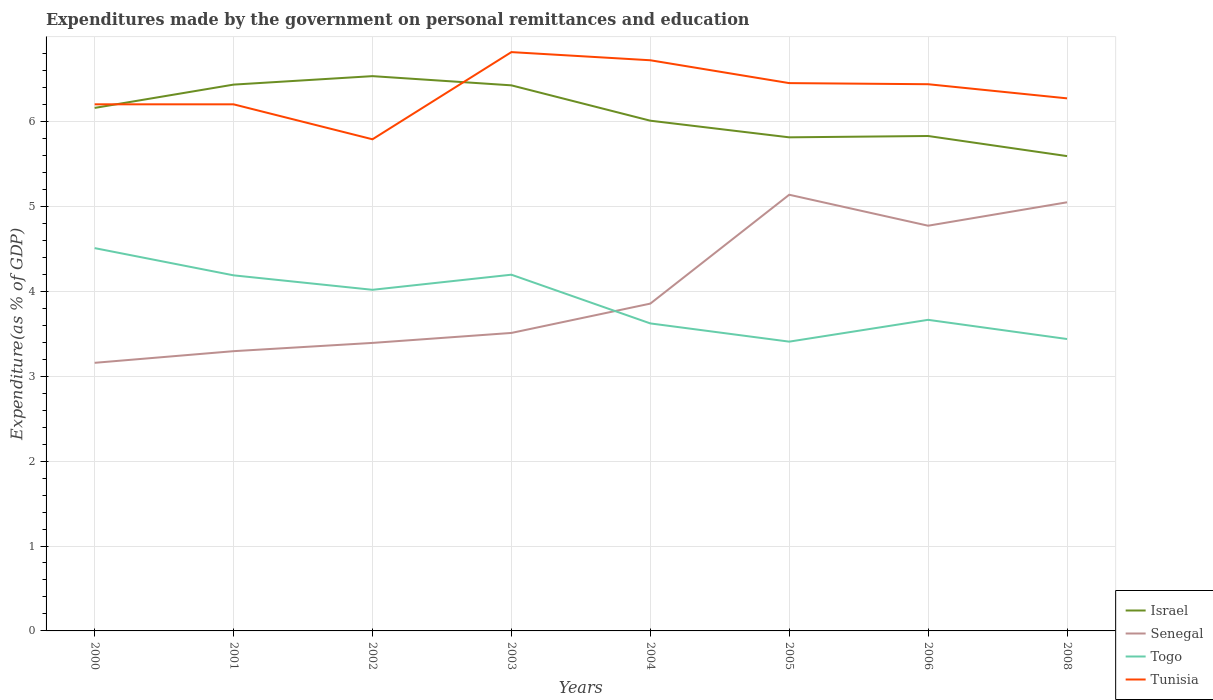How many different coloured lines are there?
Offer a very short reply. 4. Is the number of lines equal to the number of legend labels?
Give a very brief answer. Yes. Across all years, what is the maximum expenditures made by the government on personal remittances and education in Togo?
Your response must be concise. 3.41. What is the total expenditures made by the government on personal remittances and education in Senegal in the graph?
Make the answer very short. -0.12. What is the difference between the highest and the second highest expenditures made by the government on personal remittances and education in Togo?
Your answer should be compact. 1.1. What is the title of the graph?
Provide a succinct answer. Expenditures made by the government on personal remittances and education. Does "India" appear as one of the legend labels in the graph?
Give a very brief answer. No. What is the label or title of the Y-axis?
Offer a very short reply. Expenditure(as % of GDP). What is the Expenditure(as % of GDP) of Israel in 2000?
Your answer should be very brief. 6.16. What is the Expenditure(as % of GDP) in Senegal in 2000?
Make the answer very short. 3.16. What is the Expenditure(as % of GDP) of Togo in 2000?
Your response must be concise. 4.51. What is the Expenditure(as % of GDP) in Tunisia in 2000?
Provide a short and direct response. 6.2. What is the Expenditure(as % of GDP) of Israel in 2001?
Offer a terse response. 6.43. What is the Expenditure(as % of GDP) of Senegal in 2001?
Your answer should be very brief. 3.29. What is the Expenditure(as % of GDP) in Togo in 2001?
Offer a very short reply. 4.19. What is the Expenditure(as % of GDP) in Tunisia in 2001?
Provide a short and direct response. 6.2. What is the Expenditure(as % of GDP) of Israel in 2002?
Your answer should be compact. 6.53. What is the Expenditure(as % of GDP) in Senegal in 2002?
Offer a very short reply. 3.39. What is the Expenditure(as % of GDP) in Togo in 2002?
Your response must be concise. 4.02. What is the Expenditure(as % of GDP) of Tunisia in 2002?
Provide a short and direct response. 5.79. What is the Expenditure(as % of GDP) in Israel in 2003?
Your answer should be very brief. 6.43. What is the Expenditure(as % of GDP) of Senegal in 2003?
Give a very brief answer. 3.51. What is the Expenditure(as % of GDP) in Togo in 2003?
Ensure brevity in your answer.  4.2. What is the Expenditure(as % of GDP) of Tunisia in 2003?
Your response must be concise. 6.82. What is the Expenditure(as % of GDP) of Israel in 2004?
Offer a very short reply. 6.01. What is the Expenditure(as % of GDP) in Senegal in 2004?
Keep it short and to the point. 3.85. What is the Expenditure(as % of GDP) of Togo in 2004?
Give a very brief answer. 3.62. What is the Expenditure(as % of GDP) of Tunisia in 2004?
Offer a very short reply. 6.72. What is the Expenditure(as % of GDP) in Israel in 2005?
Your response must be concise. 5.81. What is the Expenditure(as % of GDP) in Senegal in 2005?
Ensure brevity in your answer.  5.14. What is the Expenditure(as % of GDP) in Togo in 2005?
Keep it short and to the point. 3.41. What is the Expenditure(as % of GDP) of Tunisia in 2005?
Offer a very short reply. 6.45. What is the Expenditure(as % of GDP) of Israel in 2006?
Your answer should be compact. 5.83. What is the Expenditure(as % of GDP) of Senegal in 2006?
Make the answer very short. 4.77. What is the Expenditure(as % of GDP) of Togo in 2006?
Your response must be concise. 3.66. What is the Expenditure(as % of GDP) of Tunisia in 2006?
Offer a very short reply. 6.44. What is the Expenditure(as % of GDP) in Israel in 2008?
Ensure brevity in your answer.  5.59. What is the Expenditure(as % of GDP) of Senegal in 2008?
Ensure brevity in your answer.  5.05. What is the Expenditure(as % of GDP) of Togo in 2008?
Keep it short and to the point. 3.44. What is the Expenditure(as % of GDP) in Tunisia in 2008?
Offer a terse response. 6.27. Across all years, what is the maximum Expenditure(as % of GDP) of Israel?
Provide a short and direct response. 6.53. Across all years, what is the maximum Expenditure(as % of GDP) of Senegal?
Provide a short and direct response. 5.14. Across all years, what is the maximum Expenditure(as % of GDP) of Togo?
Your answer should be very brief. 4.51. Across all years, what is the maximum Expenditure(as % of GDP) in Tunisia?
Offer a very short reply. 6.82. Across all years, what is the minimum Expenditure(as % of GDP) in Israel?
Provide a succinct answer. 5.59. Across all years, what is the minimum Expenditure(as % of GDP) of Senegal?
Make the answer very short. 3.16. Across all years, what is the minimum Expenditure(as % of GDP) in Togo?
Your answer should be compact. 3.41. Across all years, what is the minimum Expenditure(as % of GDP) in Tunisia?
Keep it short and to the point. 5.79. What is the total Expenditure(as % of GDP) in Israel in the graph?
Your answer should be very brief. 48.8. What is the total Expenditure(as % of GDP) in Senegal in the graph?
Make the answer very short. 32.17. What is the total Expenditure(as % of GDP) of Togo in the graph?
Your response must be concise. 31.04. What is the total Expenditure(as % of GDP) of Tunisia in the graph?
Make the answer very short. 50.89. What is the difference between the Expenditure(as % of GDP) of Israel in 2000 and that in 2001?
Keep it short and to the point. -0.27. What is the difference between the Expenditure(as % of GDP) of Senegal in 2000 and that in 2001?
Ensure brevity in your answer.  -0.14. What is the difference between the Expenditure(as % of GDP) of Togo in 2000 and that in 2001?
Give a very brief answer. 0.32. What is the difference between the Expenditure(as % of GDP) in Tunisia in 2000 and that in 2001?
Keep it short and to the point. 0. What is the difference between the Expenditure(as % of GDP) of Israel in 2000 and that in 2002?
Provide a short and direct response. -0.37. What is the difference between the Expenditure(as % of GDP) of Senegal in 2000 and that in 2002?
Your answer should be compact. -0.23. What is the difference between the Expenditure(as % of GDP) in Togo in 2000 and that in 2002?
Keep it short and to the point. 0.49. What is the difference between the Expenditure(as % of GDP) in Tunisia in 2000 and that in 2002?
Your response must be concise. 0.41. What is the difference between the Expenditure(as % of GDP) in Israel in 2000 and that in 2003?
Keep it short and to the point. -0.27. What is the difference between the Expenditure(as % of GDP) of Senegal in 2000 and that in 2003?
Offer a very short reply. -0.35. What is the difference between the Expenditure(as % of GDP) in Togo in 2000 and that in 2003?
Your answer should be compact. 0.31. What is the difference between the Expenditure(as % of GDP) in Tunisia in 2000 and that in 2003?
Offer a very short reply. -0.61. What is the difference between the Expenditure(as % of GDP) in Israel in 2000 and that in 2004?
Make the answer very short. 0.15. What is the difference between the Expenditure(as % of GDP) in Senegal in 2000 and that in 2004?
Make the answer very short. -0.7. What is the difference between the Expenditure(as % of GDP) in Togo in 2000 and that in 2004?
Your answer should be compact. 0.89. What is the difference between the Expenditure(as % of GDP) of Tunisia in 2000 and that in 2004?
Provide a short and direct response. -0.52. What is the difference between the Expenditure(as % of GDP) of Israel in 2000 and that in 2005?
Your answer should be very brief. 0.35. What is the difference between the Expenditure(as % of GDP) of Senegal in 2000 and that in 2005?
Your answer should be very brief. -1.98. What is the difference between the Expenditure(as % of GDP) of Togo in 2000 and that in 2005?
Provide a short and direct response. 1.1. What is the difference between the Expenditure(as % of GDP) in Tunisia in 2000 and that in 2005?
Give a very brief answer. -0.25. What is the difference between the Expenditure(as % of GDP) in Israel in 2000 and that in 2006?
Ensure brevity in your answer.  0.33. What is the difference between the Expenditure(as % of GDP) of Senegal in 2000 and that in 2006?
Make the answer very short. -1.61. What is the difference between the Expenditure(as % of GDP) in Togo in 2000 and that in 2006?
Give a very brief answer. 0.84. What is the difference between the Expenditure(as % of GDP) of Tunisia in 2000 and that in 2006?
Make the answer very short. -0.24. What is the difference between the Expenditure(as % of GDP) in Israel in 2000 and that in 2008?
Your answer should be compact. 0.57. What is the difference between the Expenditure(as % of GDP) of Senegal in 2000 and that in 2008?
Keep it short and to the point. -1.89. What is the difference between the Expenditure(as % of GDP) of Togo in 2000 and that in 2008?
Keep it short and to the point. 1.07. What is the difference between the Expenditure(as % of GDP) of Tunisia in 2000 and that in 2008?
Offer a terse response. -0.07. What is the difference between the Expenditure(as % of GDP) of Israel in 2001 and that in 2002?
Make the answer very short. -0.1. What is the difference between the Expenditure(as % of GDP) in Senegal in 2001 and that in 2002?
Offer a very short reply. -0.1. What is the difference between the Expenditure(as % of GDP) in Togo in 2001 and that in 2002?
Your answer should be very brief. 0.17. What is the difference between the Expenditure(as % of GDP) of Tunisia in 2001 and that in 2002?
Offer a terse response. 0.41. What is the difference between the Expenditure(as % of GDP) in Israel in 2001 and that in 2003?
Offer a very short reply. 0.01. What is the difference between the Expenditure(as % of GDP) in Senegal in 2001 and that in 2003?
Keep it short and to the point. -0.21. What is the difference between the Expenditure(as % of GDP) of Togo in 2001 and that in 2003?
Offer a terse response. -0.01. What is the difference between the Expenditure(as % of GDP) of Tunisia in 2001 and that in 2003?
Offer a terse response. -0.61. What is the difference between the Expenditure(as % of GDP) in Israel in 2001 and that in 2004?
Give a very brief answer. 0.42. What is the difference between the Expenditure(as % of GDP) of Senegal in 2001 and that in 2004?
Ensure brevity in your answer.  -0.56. What is the difference between the Expenditure(as % of GDP) of Togo in 2001 and that in 2004?
Your response must be concise. 0.57. What is the difference between the Expenditure(as % of GDP) of Tunisia in 2001 and that in 2004?
Your answer should be compact. -0.52. What is the difference between the Expenditure(as % of GDP) of Israel in 2001 and that in 2005?
Keep it short and to the point. 0.62. What is the difference between the Expenditure(as % of GDP) of Senegal in 2001 and that in 2005?
Your response must be concise. -1.84. What is the difference between the Expenditure(as % of GDP) in Togo in 2001 and that in 2005?
Provide a short and direct response. 0.78. What is the difference between the Expenditure(as % of GDP) in Tunisia in 2001 and that in 2005?
Ensure brevity in your answer.  -0.25. What is the difference between the Expenditure(as % of GDP) of Israel in 2001 and that in 2006?
Offer a terse response. 0.61. What is the difference between the Expenditure(as % of GDP) in Senegal in 2001 and that in 2006?
Keep it short and to the point. -1.48. What is the difference between the Expenditure(as % of GDP) of Togo in 2001 and that in 2006?
Provide a succinct answer. 0.52. What is the difference between the Expenditure(as % of GDP) of Tunisia in 2001 and that in 2006?
Offer a very short reply. -0.24. What is the difference between the Expenditure(as % of GDP) of Israel in 2001 and that in 2008?
Give a very brief answer. 0.84. What is the difference between the Expenditure(as % of GDP) in Senegal in 2001 and that in 2008?
Give a very brief answer. -1.75. What is the difference between the Expenditure(as % of GDP) of Tunisia in 2001 and that in 2008?
Offer a very short reply. -0.07. What is the difference between the Expenditure(as % of GDP) of Israel in 2002 and that in 2003?
Ensure brevity in your answer.  0.11. What is the difference between the Expenditure(as % of GDP) of Senegal in 2002 and that in 2003?
Provide a short and direct response. -0.12. What is the difference between the Expenditure(as % of GDP) in Togo in 2002 and that in 2003?
Your response must be concise. -0.18. What is the difference between the Expenditure(as % of GDP) of Tunisia in 2002 and that in 2003?
Your answer should be very brief. -1.03. What is the difference between the Expenditure(as % of GDP) in Israel in 2002 and that in 2004?
Provide a succinct answer. 0.52. What is the difference between the Expenditure(as % of GDP) of Senegal in 2002 and that in 2004?
Your response must be concise. -0.46. What is the difference between the Expenditure(as % of GDP) of Togo in 2002 and that in 2004?
Give a very brief answer. 0.4. What is the difference between the Expenditure(as % of GDP) in Tunisia in 2002 and that in 2004?
Make the answer very short. -0.93. What is the difference between the Expenditure(as % of GDP) in Israel in 2002 and that in 2005?
Give a very brief answer. 0.72. What is the difference between the Expenditure(as % of GDP) of Senegal in 2002 and that in 2005?
Provide a succinct answer. -1.75. What is the difference between the Expenditure(as % of GDP) in Togo in 2002 and that in 2005?
Offer a terse response. 0.61. What is the difference between the Expenditure(as % of GDP) in Tunisia in 2002 and that in 2005?
Make the answer very short. -0.66. What is the difference between the Expenditure(as % of GDP) of Israel in 2002 and that in 2006?
Your answer should be compact. 0.7. What is the difference between the Expenditure(as % of GDP) of Senegal in 2002 and that in 2006?
Keep it short and to the point. -1.38. What is the difference between the Expenditure(as % of GDP) in Togo in 2002 and that in 2006?
Make the answer very short. 0.35. What is the difference between the Expenditure(as % of GDP) of Tunisia in 2002 and that in 2006?
Your answer should be very brief. -0.65. What is the difference between the Expenditure(as % of GDP) in Israel in 2002 and that in 2008?
Your answer should be very brief. 0.94. What is the difference between the Expenditure(as % of GDP) in Senegal in 2002 and that in 2008?
Give a very brief answer. -1.66. What is the difference between the Expenditure(as % of GDP) of Togo in 2002 and that in 2008?
Your response must be concise. 0.58. What is the difference between the Expenditure(as % of GDP) in Tunisia in 2002 and that in 2008?
Ensure brevity in your answer.  -0.48. What is the difference between the Expenditure(as % of GDP) in Israel in 2003 and that in 2004?
Offer a terse response. 0.42. What is the difference between the Expenditure(as % of GDP) in Senegal in 2003 and that in 2004?
Provide a short and direct response. -0.35. What is the difference between the Expenditure(as % of GDP) in Togo in 2003 and that in 2004?
Provide a succinct answer. 0.57. What is the difference between the Expenditure(as % of GDP) of Tunisia in 2003 and that in 2004?
Provide a succinct answer. 0.1. What is the difference between the Expenditure(as % of GDP) of Israel in 2003 and that in 2005?
Provide a short and direct response. 0.61. What is the difference between the Expenditure(as % of GDP) of Senegal in 2003 and that in 2005?
Provide a short and direct response. -1.63. What is the difference between the Expenditure(as % of GDP) of Togo in 2003 and that in 2005?
Offer a very short reply. 0.79. What is the difference between the Expenditure(as % of GDP) in Tunisia in 2003 and that in 2005?
Offer a very short reply. 0.37. What is the difference between the Expenditure(as % of GDP) of Israel in 2003 and that in 2006?
Offer a very short reply. 0.6. What is the difference between the Expenditure(as % of GDP) of Senegal in 2003 and that in 2006?
Your answer should be compact. -1.26. What is the difference between the Expenditure(as % of GDP) of Togo in 2003 and that in 2006?
Keep it short and to the point. 0.53. What is the difference between the Expenditure(as % of GDP) of Tunisia in 2003 and that in 2006?
Keep it short and to the point. 0.38. What is the difference between the Expenditure(as % of GDP) in Israel in 2003 and that in 2008?
Provide a succinct answer. 0.83. What is the difference between the Expenditure(as % of GDP) of Senegal in 2003 and that in 2008?
Offer a very short reply. -1.54. What is the difference between the Expenditure(as % of GDP) of Togo in 2003 and that in 2008?
Your response must be concise. 0.76. What is the difference between the Expenditure(as % of GDP) of Tunisia in 2003 and that in 2008?
Your response must be concise. 0.54. What is the difference between the Expenditure(as % of GDP) of Israel in 2004 and that in 2005?
Give a very brief answer. 0.2. What is the difference between the Expenditure(as % of GDP) in Senegal in 2004 and that in 2005?
Your answer should be very brief. -1.28. What is the difference between the Expenditure(as % of GDP) in Togo in 2004 and that in 2005?
Your answer should be compact. 0.21. What is the difference between the Expenditure(as % of GDP) of Tunisia in 2004 and that in 2005?
Give a very brief answer. 0.27. What is the difference between the Expenditure(as % of GDP) of Israel in 2004 and that in 2006?
Provide a succinct answer. 0.18. What is the difference between the Expenditure(as % of GDP) of Senegal in 2004 and that in 2006?
Provide a short and direct response. -0.92. What is the difference between the Expenditure(as % of GDP) in Togo in 2004 and that in 2006?
Make the answer very short. -0.04. What is the difference between the Expenditure(as % of GDP) in Tunisia in 2004 and that in 2006?
Ensure brevity in your answer.  0.28. What is the difference between the Expenditure(as % of GDP) of Israel in 2004 and that in 2008?
Keep it short and to the point. 0.42. What is the difference between the Expenditure(as % of GDP) of Senegal in 2004 and that in 2008?
Your answer should be very brief. -1.19. What is the difference between the Expenditure(as % of GDP) of Togo in 2004 and that in 2008?
Offer a very short reply. 0.18. What is the difference between the Expenditure(as % of GDP) in Tunisia in 2004 and that in 2008?
Give a very brief answer. 0.45. What is the difference between the Expenditure(as % of GDP) in Israel in 2005 and that in 2006?
Provide a succinct answer. -0.02. What is the difference between the Expenditure(as % of GDP) in Senegal in 2005 and that in 2006?
Offer a terse response. 0.36. What is the difference between the Expenditure(as % of GDP) of Togo in 2005 and that in 2006?
Keep it short and to the point. -0.26. What is the difference between the Expenditure(as % of GDP) of Tunisia in 2005 and that in 2006?
Provide a short and direct response. 0.01. What is the difference between the Expenditure(as % of GDP) of Israel in 2005 and that in 2008?
Your answer should be compact. 0.22. What is the difference between the Expenditure(as % of GDP) of Senegal in 2005 and that in 2008?
Ensure brevity in your answer.  0.09. What is the difference between the Expenditure(as % of GDP) of Togo in 2005 and that in 2008?
Provide a succinct answer. -0.03. What is the difference between the Expenditure(as % of GDP) in Tunisia in 2005 and that in 2008?
Your answer should be very brief. 0.18. What is the difference between the Expenditure(as % of GDP) in Israel in 2006 and that in 2008?
Provide a short and direct response. 0.24. What is the difference between the Expenditure(as % of GDP) of Senegal in 2006 and that in 2008?
Provide a short and direct response. -0.28. What is the difference between the Expenditure(as % of GDP) in Togo in 2006 and that in 2008?
Provide a short and direct response. 0.23. What is the difference between the Expenditure(as % of GDP) in Tunisia in 2006 and that in 2008?
Your answer should be very brief. 0.17. What is the difference between the Expenditure(as % of GDP) in Israel in 2000 and the Expenditure(as % of GDP) in Senegal in 2001?
Provide a short and direct response. 2.86. What is the difference between the Expenditure(as % of GDP) of Israel in 2000 and the Expenditure(as % of GDP) of Togo in 2001?
Make the answer very short. 1.97. What is the difference between the Expenditure(as % of GDP) in Israel in 2000 and the Expenditure(as % of GDP) in Tunisia in 2001?
Keep it short and to the point. -0.04. What is the difference between the Expenditure(as % of GDP) in Senegal in 2000 and the Expenditure(as % of GDP) in Togo in 2001?
Offer a very short reply. -1.03. What is the difference between the Expenditure(as % of GDP) in Senegal in 2000 and the Expenditure(as % of GDP) in Tunisia in 2001?
Make the answer very short. -3.04. What is the difference between the Expenditure(as % of GDP) in Togo in 2000 and the Expenditure(as % of GDP) in Tunisia in 2001?
Ensure brevity in your answer.  -1.69. What is the difference between the Expenditure(as % of GDP) of Israel in 2000 and the Expenditure(as % of GDP) of Senegal in 2002?
Keep it short and to the point. 2.77. What is the difference between the Expenditure(as % of GDP) in Israel in 2000 and the Expenditure(as % of GDP) in Togo in 2002?
Make the answer very short. 2.14. What is the difference between the Expenditure(as % of GDP) in Israel in 2000 and the Expenditure(as % of GDP) in Tunisia in 2002?
Provide a short and direct response. 0.37. What is the difference between the Expenditure(as % of GDP) in Senegal in 2000 and the Expenditure(as % of GDP) in Togo in 2002?
Offer a very short reply. -0.86. What is the difference between the Expenditure(as % of GDP) of Senegal in 2000 and the Expenditure(as % of GDP) of Tunisia in 2002?
Offer a very short reply. -2.63. What is the difference between the Expenditure(as % of GDP) in Togo in 2000 and the Expenditure(as % of GDP) in Tunisia in 2002?
Ensure brevity in your answer.  -1.28. What is the difference between the Expenditure(as % of GDP) in Israel in 2000 and the Expenditure(as % of GDP) in Senegal in 2003?
Your answer should be very brief. 2.65. What is the difference between the Expenditure(as % of GDP) in Israel in 2000 and the Expenditure(as % of GDP) in Togo in 2003?
Your response must be concise. 1.96. What is the difference between the Expenditure(as % of GDP) of Israel in 2000 and the Expenditure(as % of GDP) of Tunisia in 2003?
Provide a short and direct response. -0.66. What is the difference between the Expenditure(as % of GDP) in Senegal in 2000 and the Expenditure(as % of GDP) in Togo in 2003?
Give a very brief answer. -1.04. What is the difference between the Expenditure(as % of GDP) of Senegal in 2000 and the Expenditure(as % of GDP) of Tunisia in 2003?
Make the answer very short. -3.66. What is the difference between the Expenditure(as % of GDP) in Togo in 2000 and the Expenditure(as % of GDP) in Tunisia in 2003?
Give a very brief answer. -2.31. What is the difference between the Expenditure(as % of GDP) in Israel in 2000 and the Expenditure(as % of GDP) in Senegal in 2004?
Ensure brevity in your answer.  2.3. What is the difference between the Expenditure(as % of GDP) in Israel in 2000 and the Expenditure(as % of GDP) in Togo in 2004?
Your answer should be compact. 2.54. What is the difference between the Expenditure(as % of GDP) in Israel in 2000 and the Expenditure(as % of GDP) in Tunisia in 2004?
Offer a very short reply. -0.56. What is the difference between the Expenditure(as % of GDP) of Senegal in 2000 and the Expenditure(as % of GDP) of Togo in 2004?
Make the answer very short. -0.46. What is the difference between the Expenditure(as % of GDP) in Senegal in 2000 and the Expenditure(as % of GDP) in Tunisia in 2004?
Provide a succinct answer. -3.56. What is the difference between the Expenditure(as % of GDP) in Togo in 2000 and the Expenditure(as % of GDP) in Tunisia in 2004?
Make the answer very short. -2.21. What is the difference between the Expenditure(as % of GDP) of Israel in 2000 and the Expenditure(as % of GDP) of Senegal in 2005?
Provide a succinct answer. 1.02. What is the difference between the Expenditure(as % of GDP) of Israel in 2000 and the Expenditure(as % of GDP) of Togo in 2005?
Provide a succinct answer. 2.75. What is the difference between the Expenditure(as % of GDP) in Israel in 2000 and the Expenditure(as % of GDP) in Tunisia in 2005?
Make the answer very short. -0.29. What is the difference between the Expenditure(as % of GDP) in Senegal in 2000 and the Expenditure(as % of GDP) in Togo in 2005?
Your answer should be very brief. -0.25. What is the difference between the Expenditure(as % of GDP) in Senegal in 2000 and the Expenditure(as % of GDP) in Tunisia in 2005?
Your answer should be compact. -3.29. What is the difference between the Expenditure(as % of GDP) of Togo in 2000 and the Expenditure(as % of GDP) of Tunisia in 2005?
Your response must be concise. -1.94. What is the difference between the Expenditure(as % of GDP) of Israel in 2000 and the Expenditure(as % of GDP) of Senegal in 2006?
Provide a succinct answer. 1.39. What is the difference between the Expenditure(as % of GDP) of Israel in 2000 and the Expenditure(as % of GDP) of Togo in 2006?
Provide a succinct answer. 2.5. What is the difference between the Expenditure(as % of GDP) in Israel in 2000 and the Expenditure(as % of GDP) in Tunisia in 2006?
Your response must be concise. -0.28. What is the difference between the Expenditure(as % of GDP) in Senegal in 2000 and the Expenditure(as % of GDP) in Togo in 2006?
Offer a terse response. -0.51. What is the difference between the Expenditure(as % of GDP) in Senegal in 2000 and the Expenditure(as % of GDP) in Tunisia in 2006?
Your answer should be compact. -3.28. What is the difference between the Expenditure(as % of GDP) of Togo in 2000 and the Expenditure(as % of GDP) of Tunisia in 2006?
Provide a succinct answer. -1.93. What is the difference between the Expenditure(as % of GDP) of Israel in 2000 and the Expenditure(as % of GDP) of Senegal in 2008?
Offer a very short reply. 1.11. What is the difference between the Expenditure(as % of GDP) of Israel in 2000 and the Expenditure(as % of GDP) of Togo in 2008?
Provide a succinct answer. 2.72. What is the difference between the Expenditure(as % of GDP) of Israel in 2000 and the Expenditure(as % of GDP) of Tunisia in 2008?
Your answer should be very brief. -0.11. What is the difference between the Expenditure(as % of GDP) in Senegal in 2000 and the Expenditure(as % of GDP) in Togo in 2008?
Your response must be concise. -0.28. What is the difference between the Expenditure(as % of GDP) in Senegal in 2000 and the Expenditure(as % of GDP) in Tunisia in 2008?
Offer a terse response. -3.11. What is the difference between the Expenditure(as % of GDP) of Togo in 2000 and the Expenditure(as % of GDP) of Tunisia in 2008?
Provide a succinct answer. -1.76. What is the difference between the Expenditure(as % of GDP) in Israel in 2001 and the Expenditure(as % of GDP) in Senegal in 2002?
Your answer should be very brief. 3.04. What is the difference between the Expenditure(as % of GDP) of Israel in 2001 and the Expenditure(as % of GDP) of Togo in 2002?
Make the answer very short. 2.42. What is the difference between the Expenditure(as % of GDP) of Israel in 2001 and the Expenditure(as % of GDP) of Tunisia in 2002?
Give a very brief answer. 0.64. What is the difference between the Expenditure(as % of GDP) in Senegal in 2001 and the Expenditure(as % of GDP) in Togo in 2002?
Your answer should be very brief. -0.72. What is the difference between the Expenditure(as % of GDP) in Senegal in 2001 and the Expenditure(as % of GDP) in Tunisia in 2002?
Provide a succinct answer. -2.5. What is the difference between the Expenditure(as % of GDP) of Togo in 2001 and the Expenditure(as % of GDP) of Tunisia in 2002?
Offer a terse response. -1.6. What is the difference between the Expenditure(as % of GDP) of Israel in 2001 and the Expenditure(as % of GDP) of Senegal in 2003?
Make the answer very short. 2.92. What is the difference between the Expenditure(as % of GDP) of Israel in 2001 and the Expenditure(as % of GDP) of Togo in 2003?
Offer a very short reply. 2.24. What is the difference between the Expenditure(as % of GDP) in Israel in 2001 and the Expenditure(as % of GDP) in Tunisia in 2003?
Ensure brevity in your answer.  -0.38. What is the difference between the Expenditure(as % of GDP) of Senegal in 2001 and the Expenditure(as % of GDP) of Togo in 2003?
Your answer should be very brief. -0.9. What is the difference between the Expenditure(as % of GDP) in Senegal in 2001 and the Expenditure(as % of GDP) in Tunisia in 2003?
Your answer should be very brief. -3.52. What is the difference between the Expenditure(as % of GDP) of Togo in 2001 and the Expenditure(as % of GDP) of Tunisia in 2003?
Give a very brief answer. -2.63. What is the difference between the Expenditure(as % of GDP) in Israel in 2001 and the Expenditure(as % of GDP) in Senegal in 2004?
Offer a very short reply. 2.58. What is the difference between the Expenditure(as % of GDP) of Israel in 2001 and the Expenditure(as % of GDP) of Togo in 2004?
Your answer should be very brief. 2.81. What is the difference between the Expenditure(as % of GDP) of Israel in 2001 and the Expenditure(as % of GDP) of Tunisia in 2004?
Offer a very short reply. -0.29. What is the difference between the Expenditure(as % of GDP) of Senegal in 2001 and the Expenditure(as % of GDP) of Togo in 2004?
Your answer should be very brief. -0.33. What is the difference between the Expenditure(as % of GDP) in Senegal in 2001 and the Expenditure(as % of GDP) in Tunisia in 2004?
Provide a short and direct response. -3.43. What is the difference between the Expenditure(as % of GDP) in Togo in 2001 and the Expenditure(as % of GDP) in Tunisia in 2004?
Provide a short and direct response. -2.53. What is the difference between the Expenditure(as % of GDP) of Israel in 2001 and the Expenditure(as % of GDP) of Senegal in 2005?
Provide a succinct answer. 1.3. What is the difference between the Expenditure(as % of GDP) of Israel in 2001 and the Expenditure(as % of GDP) of Togo in 2005?
Your response must be concise. 3.03. What is the difference between the Expenditure(as % of GDP) of Israel in 2001 and the Expenditure(as % of GDP) of Tunisia in 2005?
Offer a very short reply. -0.02. What is the difference between the Expenditure(as % of GDP) in Senegal in 2001 and the Expenditure(as % of GDP) in Togo in 2005?
Provide a short and direct response. -0.11. What is the difference between the Expenditure(as % of GDP) of Senegal in 2001 and the Expenditure(as % of GDP) of Tunisia in 2005?
Give a very brief answer. -3.16. What is the difference between the Expenditure(as % of GDP) in Togo in 2001 and the Expenditure(as % of GDP) in Tunisia in 2005?
Ensure brevity in your answer.  -2.26. What is the difference between the Expenditure(as % of GDP) in Israel in 2001 and the Expenditure(as % of GDP) in Senegal in 2006?
Your response must be concise. 1.66. What is the difference between the Expenditure(as % of GDP) of Israel in 2001 and the Expenditure(as % of GDP) of Togo in 2006?
Make the answer very short. 2.77. What is the difference between the Expenditure(as % of GDP) of Israel in 2001 and the Expenditure(as % of GDP) of Tunisia in 2006?
Make the answer very short. -0. What is the difference between the Expenditure(as % of GDP) in Senegal in 2001 and the Expenditure(as % of GDP) in Togo in 2006?
Your answer should be compact. -0.37. What is the difference between the Expenditure(as % of GDP) in Senegal in 2001 and the Expenditure(as % of GDP) in Tunisia in 2006?
Your response must be concise. -3.14. What is the difference between the Expenditure(as % of GDP) of Togo in 2001 and the Expenditure(as % of GDP) of Tunisia in 2006?
Your answer should be very brief. -2.25. What is the difference between the Expenditure(as % of GDP) in Israel in 2001 and the Expenditure(as % of GDP) in Senegal in 2008?
Ensure brevity in your answer.  1.39. What is the difference between the Expenditure(as % of GDP) in Israel in 2001 and the Expenditure(as % of GDP) in Togo in 2008?
Offer a very short reply. 3. What is the difference between the Expenditure(as % of GDP) in Israel in 2001 and the Expenditure(as % of GDP) in Tunisia in 2008?
Make the answer very short. 0.16. What is the difference between the Expenditure(as % of GDP) in Senegal in 2001 and the Expenditure(as % of GDP) in Togo in 2008?
Provide a succinct answer. -0.14. What is the difference between the Expenditure(as % of GDP) in Senegal in 2001 and the Expenditure(as % of GDP) in Tunisia in 2008?
Your answer should be compact. -2.98. What is the difference between the Expenditure(as % of GDP) of Togo in 2001 and the Expenditure(as % of GDP) of Tunisia in 2008?
Offer a terse response. -2.08. What is the difference between the Expenditure(as % of GDP) in Israel in 2002 and the Expenditure(as % of GDP) in Senegal in 2003?
Keep it short and to the point. 3.02. What is the difference between the Expenditure(as % of GDP) of Israel in 2002 and the Expenditure(as % of GDP) of Togo in 2003?
Offer a very short reply. 2.34. What is the difference between the Expenditure(as % of GDP) of Israel in 2002 and the Expenditure(as % of GDP) of Tunisia in 2003?
Offer a terse response. -0.28. What is the difference between the Expenditure(as % of GDP) in Senegal in 2002 and the Expenditure(as % of GDP) in Togo in 2003?
Keep it short and to the point. -0.8. What is the difference between the Expenditure(as % of GDP) in Senegal in 2002 and the Expenditure(as % of GDP) in Tunisia in 2003?
Provide a succinct answer. -3.42. What is the difference between the Expenditure(as % of GDP) in Togo in 2002 and the Expenditure(as % of GDP) in Tunisia in 2003?
Make the answer very short. -2.8. What is the difference between the Expenditure(as % of GDP) of Israel in 2002 and the Expenditure(as % of GDP) of Senegal in 2004?
Make the answer very short. 2.68. What is the difference between the Expenditure(as % of GDP) of Israel in 2002 and the Expenditure(as % of GDP) of Togo in 2004?
Make the answer very short. 2.91. What is the difference between the Expenditure(as % of GDP) of Israel in 2002 and the Expenditure(as % of GDP) of Tunisia in 2004?
Your answer should be very brief. -0.19. What is the difference between the Expenditure(as % of GDP) of Senegal in 2002 and the Expenditure(as % of GDP) of Togo in 2004?
Make the answer very short. -0.23. What is the difference between the Expenditure(as % of GDP) in Senegal in 2002 and the Expenditure(as % of GDP) in Tunisia in 2004?
Provide a short and direct response. -3.33. What is the difference between the Expenditure(as % of GDP) in Togo in 2002 and the Expenditure(as % of GDP) in Tunisia in 2004?
Offer a terse response. -2.7. What is the difference between the Expenditure(as % of GDP) of Israel in 2002 and the Expenditure(as % of GDP) of Senegal in 2005?
Ensure brevity in your answer.  1.4. What is the difference between the Expenditure(as % of GDP) of Israel in 2002 and the Expenditure(as % of GDP) of Togo in 2005?
Your answer should be compact. 3.13. What is the difference between the Expenditure(as % of GDP) of Israel in 2002 and the Expenditure(as % of GDP) of Tunisia in 2005?
Keep it short and to the point. 0.08. What is the difference between the Expenditure(as % of GDP) in Senegal in 2002 and the Expenditure(as % of GDP) in Togo in 2005?
Provide a succinct answer. -0.01. What is the difference between the Expenditure(as % of GDP) in Senegal in 2002 and the Expenditure(as % of GDP) in Tunisia in 2005?
Ensure brevity in your answer.  -3.06. What is the difference between the Expenditure(as % of GDP) of Togo in 2002 and the Expenditure(as % of GDP) of Tunisia in 2005?
Your response must be concise. -2.43. What is the difference between the Expenditure(as % of GDP) of Israel in 2002 and the Expenditure(as % of GDP) of Senegal in 2006?
Give a very brief answer. 1.76. What is the difference between the Expenditure(as % of GDP) of Israel in 2002 and the Expenditure(as % of GDP) of Togo in 2006?
Provide a short and direct response. 2.87. What is the difference between the Expenditure(as % of GDP) of Israel in 2002 and the Expenditure(as % of GDP) of Tunisia in 2006?
Provide a succinct answer. 0.1. What is the difference between the Expenditure(as % of GDP) of Senegal in 2002 and the Expenditure(as % of GDP) of Togo in 2006?
Your answer should be compact. -0.27. What is the difference between the Expenditure(as % of GDP) of Senegal in 2002 and the Expenditure(as % of GDP) of Tunisia in 2006?
Offer a very short reply. -3.05. What is the difference between the Expenditure(as % of GDP) in Togo in 2002 and the Expenditure(as % of GDP) in Tunisia in 2006?
Provide a short and direct response. -2.42. What is the difference between the Expenditure(as % of GDP) in Israel in 2002 and the Expenditure(as % of GDP) in Senegal in 2008?
Your answer should be compact. 1.49. What is the difference between the Expenditure(as % of GDP) of Israel in 2002 and the Expenditure(as % of GDP) of Togo in 2008?
Provide a succinct answer. 3.1. What is the difference between the Expenditure(as % of GDP) of Israel in 2002 and the Expenditure(as % of GDP) of Tunisia in 2008?
Give a very brief answer. 0.26. What is the difference between the Expenditure(as % of GDP) of Senegal in 2002 and the Expenditure(as % of GDP) of Togo in 2008?
Provide a short and direct response. -0.05. What is the difference between the Expenditure(as % of GDP) in Senegal in 2002 and the Expenditure(as % of GDP) in Tunisia in 2008?
Offer a very short reply. -2.88. What is the difference between the Expenditure(as % of GDP) of Togo in 2002 and the Expenditure(as % of GDP) of Tunisia in 2008?
Ensure brevity in your answer.  -2.25. What is the difference between the Expenditure(as % of GDP) of Israel in 2003 and the Expenditure(as % of GDP) of Senegal in 2004?
Provide a succinct answer. 2.57. What is the difference between the Expenditure(as % of GDP) in Israel in 2003 and the Expenditure(as % of GDP) in Togo in 2004?
Your response must be concise. 2.8. What is the difference between the Expenditure(as % of GDP) of Israel in 2003 and the Expenditure(as % of GDP) of Tunisia in 2004?
Provide a succinct answer. -0.3. What is the difference between the Expenditure(as % of GDP) of Senegal in 2003 and the Expenditure(as % of GDP) of Togo in 2004?
Ensure brevity in your answer.  -0.11. What is the difference between the Expenditure(as % of GDP) of Senegal in 2003 and the Expenditure(as % of GDP) of Tunisia in 2004?
Offer a very short reply. -3.21. What is the difference between the Expenditure(as % of GDP) in Togo in 2003 and the Expenditure(as % of GDP) in Tunisia in 2004?
Your answer should be compact. -2.53. What is the difference between the Expenditure(as % of GDP) of Israel in 2003 and the Expenditure(as % of GDP) of Senegal in 2005?
Make the answer very short. 1.29. What is the difference between the Expenditure(as % of GDP) of Israel in 2003 and the Expenditure(as % of GDP) of Togo in 2005?
Offer a terse response. 3.02. What is the difference between the Expenditure(as % of GDP) of Israel in 2003 and the Expenditure(as % of GDP) of Tunisia in 2005?
Provide a succinct answer. -0.03. What is the difference between the Expenditure(as % of GDP) of Senegal in 2003 and the Expenditure(as % of GDP) of Togo in 2005?
Provide a short and direct response. 0.1. What is the difference between the Expenditure(as % of GDP) of Senegal in 2003 and the Expenditure(as % of GDP) of Tunisia in 2005?
Make the answer very short. -2.94. What is the difference between the Expenditure(as % of GDP) of Togo in 2003 and the Expenditure(as % of GDP) of Tunisia in 2005?
Keep it short and to the point. -2.26. What is the difference between the Expenditure(as % of GDP) in Israel in 2003 and the Expenditure(as % of GDP) in Senegal in 2006?
Your answer should be compact. 1.65. What is the difference between the Expenditure(as % of GDP) of Israel in 2003 and the Expenditure(as % of GDP) of Togo in 2006?
Your answer should be compact. 2.76. What is the difference between the Expenditure(as % of GDP) in Israel in 2003 and the Expenditure(as % of GDP) in Tunisia in 2006?
Make the answer very short. -0.01. What is the difference between the Expenditure(as % of GDP) in Senegal in 2003 and the Expenditure(as % of GDP) in Togo in 2006?
Ensure brevity in your answer.  -0.15. What is the difference between the Expenditure(as % of GDP) of Senegal in 2003 and the Expenditure(as % of GDP) of Tunisia in 2006?
Ensure brevity in your answer.  -2.93. What is the difference between the Expenditure(as % of GDP) in Togo in 2003 and the Expenditure(as % of GDP) in Tunisia in 2006?
Your response must be concise. -2.24. What is the difference between the Expenditure(as % of GDP) of Israel in 2003 and the Expenditure(as % of GDP) of Senegal in 2008?
Provide a succinct answer. 1.38. What is the difference between the Expenditure(as % of GDP) in Israel in 2003 and the Expenditure(as % of GDP) in Togo in 2008?
Your response must be concise. 2.99. What is the difference between the Expenditure(as % of GDP) in Israel in 2003 and the Expenditure(as % of GDP) in Tunisia in 2008?
Provide a short and direct response. 0.15. What is the difference between the Expenditure(as % of GDP) of Senegal in 2003 and the Expenditure(as % of GDP) of Togo in 2008?
Offer a terse response. 0.07. What is the difference between the Expenditure(as % of GDP) of Senegal in 2003 and the Expenditure(as % of GDP) of Tunisia in 2008?
Ensure brevity in your answer.  -2.76. What is the difference between the Expenditure(as % of GDP) of Togo in 2003 and the Expenditure(as % of GDP) of Tunisia in 2008?
Offer a very short reply. -2.08. What is the difference between the Expenditure(as % of GDP) of Israel in 2004 and the Expenditure(as % of GDP) of Senegal in 2005?
Provide a succinct answer. 0.87. What is the difference between the Expenditure(as % of GDP) of Israel in 2004 and the Expenditure(as % of GDP) of Togo in 2005?
Ensure brevity in your answer.  2.6. What is the difference between the Expenditure(as % of GDP) in Israel in 2004 and the Expenditure(as % of GDP) in Tunisia in 2005?
Provide a succinct answer. -0.44. What is the difference between the Expenditure(as % of GDP) of Senegal in 2004 and the Expenditure(as % of GDP) of Togo in 2005?
Give a very brief answer. 0.45. What is the difference between the Expenditure(as % of GDP) of Senegal in 2004 and the Expenditure(as % of GDP) of Tunisia in 2005?
Your answer should be very brief. -2.6. What is the difference between the Expenditure(as % of GDP) in Togo in 2004 and the Expenditure(as % of GDP) in Tunisia in 2005?
Give a very brief answer. -2.83. What is the difference between the Expenditure(as % of GDP) in Israel in 2004 and the Expenditure(as % of GDP) in Senegal in 2006?
Offer a terse response. 1.24. What is the difference between the Expenditure(as % of GDP) of Israel in 2004 and the Expenditure(as % of GDP) of Togo in 2006?
Give a very brief answer. 2.35. What is the difference between the Expenditure(as % of GDP) of Israel in 2004 and the Expenditure(as % of GDP) of Tunisia in 2006?
Your answer should be compact. -0.43. What is the difference between the Expenditure(as % of GDP) in Senegal in 2004 and the Expenditure(as % of GDP) in Togo in 2006?
Provide a short and direct response. 0.19. What is the difference between the Expenditure(as % of GDP) in Senegal in 2004 and the Expenditure(as % of GDP) in Tunisia in 2006?
Provide a short and direct response. -2.58. What is the difference between the Expenditure(as % of GDP) of Togo in 2004 and the Expenditure(as % of GDP) of Tunisia in 2006?
Your answer should be compact. -2.82. What is the difference between the Expenditure(as % of GDP) of Israel in 2004 and the Expenditure(as % of GDP) of Senegal in 2008?
Keep it short and to the point. 0.96. What is the difference between the Expenditure(as % of GDP) in Israel in 2004 and the Expenditure(as % of GDP) in Togo in 2008?
Give a very brief answer. 2.57. What is the difference between the Expenditure(as % of GDP) of Israel in 2004 and the Expenditure(as % of GDP) of Tunisia in 2008?
Keep it short and to the point. -0.26. What is the difference between the Expenditure(as % of GDP) in Senegal in 2004 and the Expenditure(as % of GDP) in Togo in 2008?
Offer a terse response. 0.42. What is the difference between the Expenditure(as % of GDP) in Senegal in 2004 and the Expenditure(as % of GDP) in Tunisia in 2008?
Give a very brief answer. -2.42. What is the difference between the Expenditure(as % of GDP) in Togo in 2004 and the Expenditure(as % of GDP) in Tunisia in 2008?
Keep it short and to the point. -2.65. What is the difference between the Expenditure(as % of GDP) in Israel in 2005 and the Expenditure(as % of GDP) in Senegal in 2006?
Ensure brevity in your answer.  1.04. What is the difference between the Expenditure(as % of GDP) of Israel in 2005 and the Expenditure(as % of GDP) of Togo in 2006?
Keep it short and to the point. 2.15. What is the difference between the Expenditure(as % of GDP) of Israel in 2005 and the Expenditure(as % of GDP) of Tunisia in 2006?
Your answer should be very brief. -0.63. What is the difference between the Expenditure(as % of GDP) in Senegal in 2005 and the Expenditure(as % of GDP) in Togo in 2006?
Your response must be concise. 1.47. What is the difference between the Expenditure(as % of GDP) in Senegal in 2005 and the Expenditure(as % of GDP) in Tunisia in 2006?
Your answer should be compact. -1.3. What is the difference between the Expenditure(as % of GDP) in Togo in 2005 and the Expenditure(as % of GDP) in Tunisia in 2006?
Ensure brevity in your answer.  -3.03. What is the difference between the Expenditure(as % of GDP) in Israel in 2005 and the Expenditure(as % of GDP) in Senegal in 2008?
Ensure brevity in your answer.  0.77. What is the difference between the Expenditure(as % of GDP) in Israel in 2005 and the Expenditure(as % of GDP) in Togo in 2008?
Make the answer very short. 2.38. What is the difference between the Expenditure(as % of GDP) in Israel in 2005 and the Expenditure(as % of GDP) in Tunisia in 2008?
Ensure brevity in your answer.  -0.46. What is the difference between the Expenditure(as % of GDP) of Senegal in 2005 and the Expenditure(as % of GDP) of Togo in 2008?
Provide a short and direct response. 1.7. What is the difference between the Expenditure(as % of GDP) in Senegal in 2005 and the Expenditure(as % of GDP) in Tunisia in 2008?
Your answer should be compact. -1.14. What is the difference between the Expenditure(as % of GDP) of Togo in 2005 and the Expenditure(as % of GDP) of Tunisia in 2008?
Keep it short and to the point. -2.87. What is the difference between the Expenditure(as % of GDP) of Israel in 2006 and the Expenditure(as % of GDP) of Senegal in 2008?
Provide a short and direct response. 0.78. What is the difference between the Expenditure(as % of GDP) of Israel in 2006 and the Expenditure(as % of GDP) of Togo in 2008?
Offer a terse response. 2.39. What is the difference between the Expenditure(as % of GDP) of Israel in 2006 and the Expenditure(as % of GDP) of Tunisia in 2008?
Your answer should be very brief. -0.44. What is the difference between the Expenditure(as % of GDP) of Senegal in 2006 and the Expenditure(as % of GDP) of Togo in 2008?
Ensure brevity in your answer.  1.33. What is the difference between the Expenditure(as % of GDP) in Senegal in 2006 and the Expenditure(as % of GDP) in Tunisia in 2008?
Your answer should be very brief. -1.5. What is the difference between the Expenditure(as % of GDP) of Togo in 2006 and the Expenditure(as % of GDP) of Tunisia in 2008?
Give a very brief answer. -2.61. What is the average Expenditure(as % of GDP) in Israel per year?
Your answer should be compact. 6.1. What is the average Expenditure(as % of GDP) in Senegal per year?
Ensure brevity in your answer.  4.02. What is the average Expenditure(as % of GDP) of Togo per year?
Offer a very short reply. 3.88. What is the average Expenditure(as % of GDP) of Tunisia per year?
Your response must be concise. 6.36. In the year 2000, what is the difference between the Expenditure(as % of GDP) in Israel and Expenditure(as % of GDP) in Senegal?
Offer a very short reply. 3. In the year 2000, what is the difference between the Expenditure(as % of GDP) in Israel and Expenditure(as % of GDP) in Togo?
Provide a short and direct response. 1.65. In the year 2000, what is the difference between the Expenditure(as % of GDP) of Israel and Expenditure(as % of GDP) of Tunisia?
Keep it short and to the point. -0.04. In the year 2000, what is the difference between the Expenditure(as % of GDP) of Senegal and Expenditure(as % of GDP) of Togo?
Your response must be concise. -1.35. In the year 2000, what is the difference between the Expenditure(as % of GDP) in Senegal and Expenditure(as % of GDP) in Tunisia?
Your answer should be very brief. -3.04. In the year 2000, what is the difference between the Expenditure(as % of GDP) in Togo and Expenditure(as % of GDP) in Tunisia?
Give a very brief answer. -1.69. In the year 2001, what is the difference between the Expenditure(as % of GDP) of Israel and Expenditure(as % of GDP) of Senegal?
Your answer should be very brief. 3.14. In the year 2001, what is the difference between the Expenditure(as % of GDP) of Israel and Expenditure(as % of GDP) of Togo?
Keep it short and to the point. 2.25. In the year 2001, what is the difference between the Expenditure(as % of GDP) in Israel and Expenditure(as % of GDP) in Tunisia?
Offer a very short reply. 0.23. In the year 2001, what is the difference between the Expenditure(as % of GDP) in Senegal and Expenditure(as % of GDP) in Togo?
Make the answer very short. -0.89. In the year 2001, what is the difference between the Expenditure(as % of GDP) in Senegal and Expenditure(as % of GDP) in Tunisia?
Ensure brevity in your answer.  -2.91. In the year 2001, what is the difference between the Expenditure(as % of GDP) of Togo and Expenditure(as % of GDP) of Tunisia?
Your response must be concise. -2.01. In the year 2002, what is the difference between the Expenditure(as % of GDP) in Israel and Expenditure(as % of GDP) in Senegal?
Give a very brief answer. 3.14. In the year 2002, what is the difference between the Expenditure(as % of GDP) of Israel and Expenditure(as % of GDP) of Togo?
Provide a short and direct response. 2.52. In the year 2002, what is the difference between the Expenditure(as % of GDP) in Israel and Expenditure(as % of GDP) in Tunisia?
Provide a short and direct response. 0.74. In the year 2002, what is the difference between the Expenditure(as % of GDP) in Senegal and Expenditure(as % of GDP) in Togo?
Your answer should be very brief. -0.63. In the year 2002, what is the difference between the Expenditure(as % of GDP) of Senegal and Expenditure(as % of GDP) of Tunisia?
Your answer should be compact. -2.4. In the year 2002, what is the difference between the Expenditure(as % of GDP) in Togo and Expenditure(as % of GDP) in Tunisia?
Provide a short and direct response. -1.77. In the year 2003, what is the difference between the Expenditure(as % of GDP) in Israel and Expenditure(as % of GDP) in Senegal?
Provide a succinct answer. 2.92. In the year 2003, what is the difference between the Expenditure(as % of GDP) of Israel and Expenditure(as % of GDP) of Togo?
Your answer should be very brief. 2.23. In the year 2003, what is the difference between the Expenditure(as % of GDP) of Israel and Expenditure(as % of GDP) of Tunisia?
Your response must be concise. -0.39. In the year 2003, what is the difference between the Expenditure(as % of GDP) of Senegal and Expenditure(as % of GDP) of Togo?
Your response must be concise. -0.69. In the year 2003, what is the difference between the Expenditure(as % of GDP) of Senegal and Expenditure(as % of GDP) of Tunisia?
Your answer should be very brief. -3.31. In the year 2003, what is the difference between the Expenditure(as % of GDP) in Togo and Expenditure(as % of GDP) in Tunisia?
Give a very brief answer. -2.62. In the year 2004, what is the difference between the Expenditure(as % of GDP) in Israel and Expenditure(as % of GDP) in Senegal?
Your answer should be compact. 2.15. In the year 2004, what is the difference between the Expenditure(as % of GDP) of Israel and Expenditure(as % of GDP) of Togo?
Your answer should be compact. 2.39. In the year 2004, what is the difference between the Expenditure(as % of GDP) in Israel and Expenditure(as % of GDP) in Tunisia?
Offer a terse response. -0.71. In the year 2004, what is the difference between the Expenditure(as % of GDP) of Senegal and Expenditure(as % of GDP) of Togo?
Offer a terse response. 0.23. In the year 2004, what is the difference between the Expenditure(as % of GDP) in Senegal and Expenditure(as % of GDP) in Tunisia?
Keep it short and to the point. -2.87. In the year 2004, what is the difference between the Expenditure(as % of GDP) of Togo and Expenditure(as % of GDP) of Tunisia?
Your answer should be very brief. -3.1. In the year 2005, what is the difference between the Expenditure(as % of GDP) in Israel and Expenditure(as % of GDP) in Senegal?
Offer a terse response. 0.68. In the year 2005, what is the difference between the Expenditure(as % of GDP) in Israel and Expenditure(as % of GDP) in Togo?
Your answer should be compact. 2.41. In the year 2005, what is the difference between the Expenditure(as % of GDP) of Israel and Expenditure(as % of GDP) of Tunisia?
Give a very brief answer. -0.64. In the year 2005, what is the difference between the Expenditure(as % of GDP) in Senegal and Expenditure(as % of GDP) in Togo?
Give a very brief answer. 1.73. In the year 2005, what is the difference between the Expenditure(as % of GDP) in Senegal and Expenditure(as % of GDP) in Tunisia?
Your answer should be very brief. -1.31. In the year 2005, what is the difference between the Expenditure(as % of GDP) of Togo and Expenditure(as % of GDP) of Tunisia?
Your answer should be compact. -3.04. In the year 2006, what is the difference between the Expenditure(as % of GDP) of Israel and Expenditure(as % of GDP) of Senegal?
Provide a short and direct response. 1.06. In the year 2006, what is the difference between the Expenditure(as % of GDP) of Israel and Expenditure(as % of GDP) of Togo?
Ensure brevity in your answer.  2.17. In the year 2006, what is the difference between the Expenditure(as % of GDP) in Israel and Expenditure(as % of GDP) in Tunisia?
Offer a very short reply. -0.61. In the year 2006, what is the difference between the Expenditure(as % of GDP) of Senegal and Expenditure(as % of GDP) of Togo?
Ensure brevity in your answer.  1.11. In the year 2006, what is the difference between the Expenditure(as % of GDP) of Senegal and Expenditure(as % of GDP) of Tunisia?
Provide a succinct answer. -1.67. In the year 2006, what is the difference between the Expenditure(as % of GDP) of Togo and Expenditure(as % of GDP) of Tunisia?
Keep it short and to the point. -2.77. In the year 2008, what is the difference between the Expenditure(as % of GDP) of Israel and Expenditure(as % of GDP) of Senegal?
Keep it short and to the point. 0.54. In the year 2008, what is the difference between the Expenditure(as % of GDP) of Israel and Expenditure(as % of GDP) of Togo?
Offer a very short reply. 2.15. In the year 2008, what is the difference between the Expenditure(as % of GDP) of Israel and Expenditure(as % of GDP) of Tunisia?
Make the answer very short. -0.68. In the year 2008, what is the difference between the Expenditure(as % of GDP) of Senegal and Expenditure(as % of GDP) of Togo?
Keep it short and to the point. 1.61. In the year 2008, what is the difference between the Expenditure(as % of GDP) in Senegal and Expenditure(as % of GDP) in Tunisia?
Give a very brief answer. -1.22. In the year 2008, what is the difference between the Expenditure(as % of GDP) in Togo and Expenditure(as % of GDP) in Tunisia?
Make the answer very short. -2.83. What is the ratio of the Expenditure(as % of GDP) of Israel in 2000 to that in 2001?
Offer a very short reply. 0.96. What is the ratio of the Expenditure(as % of GDP) of Senegal in 2000 to that in 2001?
Offer a terse response. 0.96. What is the ratio of the Expenditure(as % of GDP) in Togo in 2000 to that in 2001?
Ensure brevity in your answer.  1.08. What is the ratio of the Expenditure(as % of GDP) in Israel in 2000 to that in 2002?
Offer a very short reply. 0.94. What is the ratio of the Expenditure(as % of GDP) of Senegal in 2000 to that in 2002?
Keep it short and to the point. 0.93. What is the ratio of the Expenditure(as % of GDP) of Togo in 2000 to that in 2002?
Provide a short and direct response. 1.12. What is the ratio of the Expenditure(as % of GDP) of Tunisia in 2000 to that in 2002?
Offer a terse response. 1.07. What is the ratio of the Expenditure(as % of GDP) of Israel in 2000 to that in 2003?
Give a very brief answer. 0.96. What is the ratio of the Expenditure(as % of GDP) in Senegal in 2000 to that in 2003?
Your answer should be very brief. 0.9. What is the ratio of the Expenditure(as % of GDP) of Togo in 2000 to that in 2003?
Your answer should be very brief. 1.07. What is the ratio of the Expenditure(as % of GDP) of Tunisia in 2000 to that in 2003?
Make the answer very short. 0.91. What is the ratio of the Expenditure(as % of GDP) in Israel in 2000 to that in 2004?
Your answer should be very brief. 1.03. What is the ratio of the Expenditure(as % of GDP) in Senegal in 2000 to that in 2004?
Ensure brevity in your answer.  0.82. What is the ratio of the Expenditure(as % of GDP) in Togo in 2000 to that in 2004?
Your response must be concise. 1.24. What is the ratio of the Expenditure(as % of GDP) in Tunisia in 2000 to that in 2004?
Your response must be concise. 0.92. What is the ratio of the Expenditure(as % of GDP) in Israel in 2000 to that in 2005?
Provide a short and direct response. 1.06. What is the ratio of the Expenditure(as % of GDP) in Senegal in 2000 to that in 2005?
Ensure brevity in your answer.  0.61. What is the ratio of the Expenditure(as % of GDP) of Togo in 2000 to that in 2005?
Your answer should be very brief. 1.32. What is the ratio of the Expenditure(as % of GDP) of Tunisia in 2000 to that in 2005?
Offer a terse response. 0.96. What is the ratio of the Expenditure(as % of GDP) in Israel in 2000 to that in 2006?
Make the answer very short. 1.06. What is the ratio of the Expenditure(as % of GDP) of Senegal in 2000 to that in 2006?
Ensure brevity in your answer.  0.66. What is the ratio of the Expenditure(as % of GDP) of Togo in 2000 to that in 2006?
Make the answer very short. 1.23. What is the ratio of the Expenditure(as % of GDP) in Tunisia in 2000 to that in 2006?
Make the answer very short. 0.96. What is the ratio of the Expenditure(as % of GDP) of Israel in 2000 to that in 2008?
Provide a short and direct response. 1.1. What is the ratio of the Expenditure(as % of GDP) in Senegal in 2000 to that in 2008?
Keep it short and to the point. 0.63. What is the ratio of the Expenditure(as % of GDP) in Togo in 2000 to that in 2008?
Provide a short and direct response. 1.31. What is the ratio of the Expenditure(as % of GDP) of Israel in 2001 to that in 2002?
Make the answer very short. 0.98. What is the ratio of the Expenditure(as % of GDP) in Senegal in 2001 to that in 2002?
Make the answer very short. 0.97. What is the ratio of the Expenditure(as % of GDP) of Togo in 2001 to that in 2002?
Offer a terse response. 1.04. What is the ratio of the Expenditure(as % of GDP) in Tunisia in 2001 to that in 2002?
Provide a succinct answer. 1.07. What is the ratio of the Expenditure(as % of GDP) of Israel in 2001 to that in 2003?
Offer a very short reply. 1. What is the ratio of the Expenditure(as % of GDP) of Senegal in 2001 to that in 2003?
Your answer should be compact. 0.94. What is the ratio of the Expenditure(as % of GDP) in Togo in 2001 to that in 2003?
Keep it short and to the point. 1. What is the ratio of the Expenditure(as % of GDP) of Tunisia in 2001 to that in 2003?
Make the answer very short. 0.91. What is the ratio of the Expenditure(as % of GDP) of Israel in 2001 to that in 2004?
Your answer should be very brief. 1.07. What is the ratio of the Expenditure(as % of GDP) in Senegal in 2001 to that in 2004?
Keep it short and to the point. 0.85. What is the ratio of the Expenditure(as % of GDP) in Togo in 2001 to that in 2004?
Offer a very short reply. 1.16. What is the ratio of the Expenditure(as % of GDP) of Tunisia in 2001 to that in 2004?
Give a very brief answer. 0.92. What is the ratio of the Expenditure(as % of GDP) in Israel in 2001 to that in 2005?
Make the answer very short. 1.11. What is the ratio of the Expenditure(as % of GDP) in Senegal in 2001 to that in 2005?
Your response must be concise. 0.64. What is the ratio of the Expenditure(as % of GDP) in Togo in 2001 to that in 2005?
Keep it short and to the point. 1.23. What is the ratio of the Expenditure(as % of GDP) of Tunisia in 2001 to that in 2005?
Keep it short and to the point. 0.96. What is the ratio of the Expenditure(as % of GDP) in Israel in 2001 to that in 2006?
Your response must be concise. 1.1. What is the ratio of the Expenditure(as % of GDP) in Senegal in 2001 to that in 2006?
Offer a very short reply. 0.69. What is the ratio of the Expenditure(as % of GDP) of Togo in 2001 to that in 2006?
Your answer should be compact. 1.14. What is the ratio of the Expenditure(as % of GDP) of Tunisia in 2001 to that in 2006?
Offer a very short reply. 0.96. What is the ratio of the Expenditure(as % of GDP) in Israel in 2001 to that in 2008?
Your response must be concise. 1.15. What is the ratio of the Expenditure(as % of GDP) of Senegal in 2001 to that in 2008?
Your response must be concise. 0.65. What is the ratio of the Expenditure(as % of GDP) in Togo in 2001 to that in 2008?
Offer a terse response. 1.22. What is the ratio of the Expenditure(as % of GDP) in Israel in 2002 to that in 2003?
Make the answer very short. 1.02. What is the ratio of the Expenditure(as % of GDP) in Senegal in 2002 to that in 2003?
Give a very brief answer. 0.97. What is the ratio of the Expenditure(as % of GDP) of Togo in 2002 to that in 2003?
Provide a succinct answer. 0.96. What is the ratio of the Expenditure(as % of GDP) in Tunisia in 2002 to that in 2003?
Give a very brief answer. 0.85. What is the ratio of the Expenditure(as % of GDP) in Israel in 2002 to that in 2004?
Ensure brevity in your answer.  1.09. What is the ratio of the Expenditure(as % of GDP) of Senegal in 2002 to that in 2004?
Offer a very short reply. 0.88. What is the ratio of the Expenditure(as % of GDP) of Togo in 2002 to that in 2004?
Provide a succinct answer. 1.11. What is the ratio of the Expenditure(as % of GDP) of Tunisia in 2002 to that in 2004?
Give a very brief answer. 0.86. What is the ratio of the Expenditure(as % of GDP) in Israel in 2002 to that in 2005?
Your answer should be very brief. 1.12. What is the ratio of the Expenditure(as % of GDP) of Senegal in 2002 to that in 2005?
Provide a succinct answer. 0.66. What is the ratio of the Expenditure(as % of GDP) of Togo in 2002 to that in 2005?
Your answer should be compact. 1.18. What is the ratio of the Expenditure(as % of GDP) in Tunisia in 2002 to that in 2005?
Ensure brevity in your answer.  0.9. What is the ratio of the Expenditure(as % of GDP) of Israel in 2002 to that in 2006?
Offer a terse response. 1.12. What is the ratio of the Expenditure(as % of GDP) of Senegal in 2002 to that in 2006?
Provide a short and direct response. 0.71. What is the ratio of the Expenditure(as % of GDP) of Togo in 2002 to that in 2006?
Offer a very short reply. 1.1. What is the ratio of the Expenditure(as % of GDP) of Tunisia in 2002 to that in 2006?
Offer a terse response. 0.9. What is the ratio of the Expenditure(as % of GDP) in Israel in 2002 to that in 2008?
Keep it short and to the point. 1.17. What is the ratio of the Expenditure(as % of GDP) of Senegal in 2002 to that in 2008?
Give a very brief answer. 0.67. What is the ratio of the Expenditure(as % of GDP) of Togo in 2002 to that in 2008?
Give a very brief answer. 1.17. What is the ratio of the Expenditure(as % of GDP) of Israel in 2003 to that in 2004?
Your response must be concise. 1.07. What is the ratio of the Expenditure(as % of GDP) in Senegal in 2003 to that in 2004?
Offer a very short reply. 0.91. What is the ratio of the Expenditure(as % of GDP) in Togo in 2003 to that in 2004?
Make the answer very short. 1.16. What is the ratio of the Expenditure(as % of GDP) in Tunisia in 2003 to that in 2004?
Offer a very short reply. 1.01. What is the ratio of the Expenditure(as % of GDP) in Israel in 2003 to that in 2005?
Your answer should be compact. 1.11. What is the ratio of the Expenditure(as % of GDP) of Senegal in 2003 to that in 2005?
Your answer should be very brief. 0.68. What is the ratio of the Expenditure(as % of GDP) of Togo in 2003 to that in 2005?
Provide a short and direct response. 1.23. What is the ratio of the Expenditure(as % of GDP) in Tunisia in 2003 to that in 2005?
Give a very brief answer. 1.06. What is the ratio of the Expenditure(as % of GDP) in Israel in 2003 to that in 2006?
Your response must be concise. 1.1. What is the ratio of the Expenditure(as % of GDP) of Senegal in 2003 to that in 2006?
Provide a short and direct response. 0.74. What is the ratio of the Expenditure(as % of GDP) in Togo in 2003 to that in 2006?
Offer a terse response. 1.15. What is the ratio of the Expenditure(as % of GDP) of Tunisia in 2003 to that in 2006?
Provide a succinct answer. 1.06. What is the ratio of the Expenditure(as % of GDP) in Israel in 2003 to that in 2008?
Make the answer very short. 1.15. What is the ratio of the Expenditure(as % of GDP) of Senegal in 2003 to that in 2008?
Your answer should be very brief. 0.7. What is the ratio of the Expenditure(as % of GDP) of Togo in 2003 to that in 2008?
Your answer should be very brief. 1.22. What is the ratio of the Expenditure(as % of GDP) in Tunisia in 2003 to that in 2008?
Offer a very short reply. 1.09. What is the ratio of the Expenditure(as % of GDP) in Israel in 2004 to that in 2005?
Your answer should be very brief. 1.03. What is the ratio of the Expenditure(as % of GDP) in Senegal in 2004 to that in 2005?
Your response must be concise. 0.75. What is the ratio of the Expenditure(as % of GDP) in Togo in 2004 to that in 2005?
Your answer should be compact. 1.06. What is the ratio of the Expenditure(as % of GDP) of Tunisia in 2004 to that in 2005?
Keep it short and to the point. 1.04. What is the ratio of the Expenditure(as % of GDP) of Israel in 2004 to that in 2006?
Ensure brevity in your answer.  1.03. What is the ratio of the Expenditure(as % of GDP) of Senegal in 2004 to that in 2006?
Offer a very short reply. 0.81. What is the ratio of the Expenditure(as % of GDP) in Tunisia in 2004 to that in 2006?
Ensure brevity in your answer.  1.04. What is the ratio of the Expenditure(as % of GDP) of Israel in 2004 to that in 2008?
Make the answer very short. 1.07. What is the ratio of the Expenditure(as % of GDP) in Senegal in 2004 to that in 2008?
Offer a very short reply. 0.76. What is the ratio of the Expenditure(as % of GDP) of Togo in 2004 to that in 2008?
Offer a very short reply. 1.05. What is the ratio of the Expenditure(as % of GDP) of Tunisia in 2004 to that in 2008?
Your answer should be very brief. 1.07. What is the ratio of the Expenditure(as % of GDP) in Senegal in 2005 to that in 2006?
Offer a terse response. 1.08. What is the ratio of the Expenditure(as % of GDP) of Togo in 2005 to that in 2006?
Provide a short and direct response. 0.93. What is the ratio of the Expenditure(as % of GDP) of Tunisia in 2005 to that in 2006?
Keep it short and to the point. 1. What is the ratio of the Expenditure(as % of GDP) in Israel in 2005 to that in 2008?
Give a very brief answer. 1.04. What is the ratio of the Expenditure(as % of GDP) in Senegal in 2005 to that in 2008?
Your answer should be compact. 1.02. What is the ratio of the Expenditure(as % of GDP) of Togo in 2005 to that in 2008?
Keep it short and to the point. 0.99. What is the ratio of the Expenditure(as % of GDP) in Tunisia in 2005 to that in 2008?
Your answer should be very brief. 1.03. What is the ratio of the Expenditure(as % of GDP) of Israel in 2006 to that in 2008?
Offer a terse response. 1.04. What is the ratio of the Expenditure(as % of GDP) of Senegal in 2006 to that in 2008?
Keep it short and to the point. 0.95. What is the ratio of the Expenditure(as % of GDP) in Togo in 2006 to that in 2008?
Offer a very short reply. 1.07. What is the ratio of the Expenditure(as % of GDP) of Tunisia in 2006 to that in 2008?
Offer a terse response. 1.03. What is the difference between the highest and the second highest Expenditure(as % of GDP) of Israel?
Keep it short and to the point. 0.1. What is the difference between the highest and the second highest Expenditure(as % of GDP) in Senegal?
Provide a short and direct response. 0.09. What is the difference between the highest and the second highest Expenditure(as % of GDP) in Togo?
Your answer should be compact. 0.31. What is the difference between the highest and the second highest Expenditure(as % of GDP) of Tunisia?
Ensure brevity in your answer.  0.1. What is the difference between the highest and the lowest Expenditure(as % of GDP) of Israel?
Ensure brevity in your answer.  0.94. What is the difference between the highest and the lowest Expenditure(as % of GDP) of Senegal?
Offer a very short reply. 1.98. What is the difference between the highest and the lowest Expenditure(as % of GDP) in Togo?
Offer a terse response. 1.1. What is the difference between the highest and the lowest Expenditure(as % of GDP) of Tunisia?
Offer a very short reply. 1.03. 